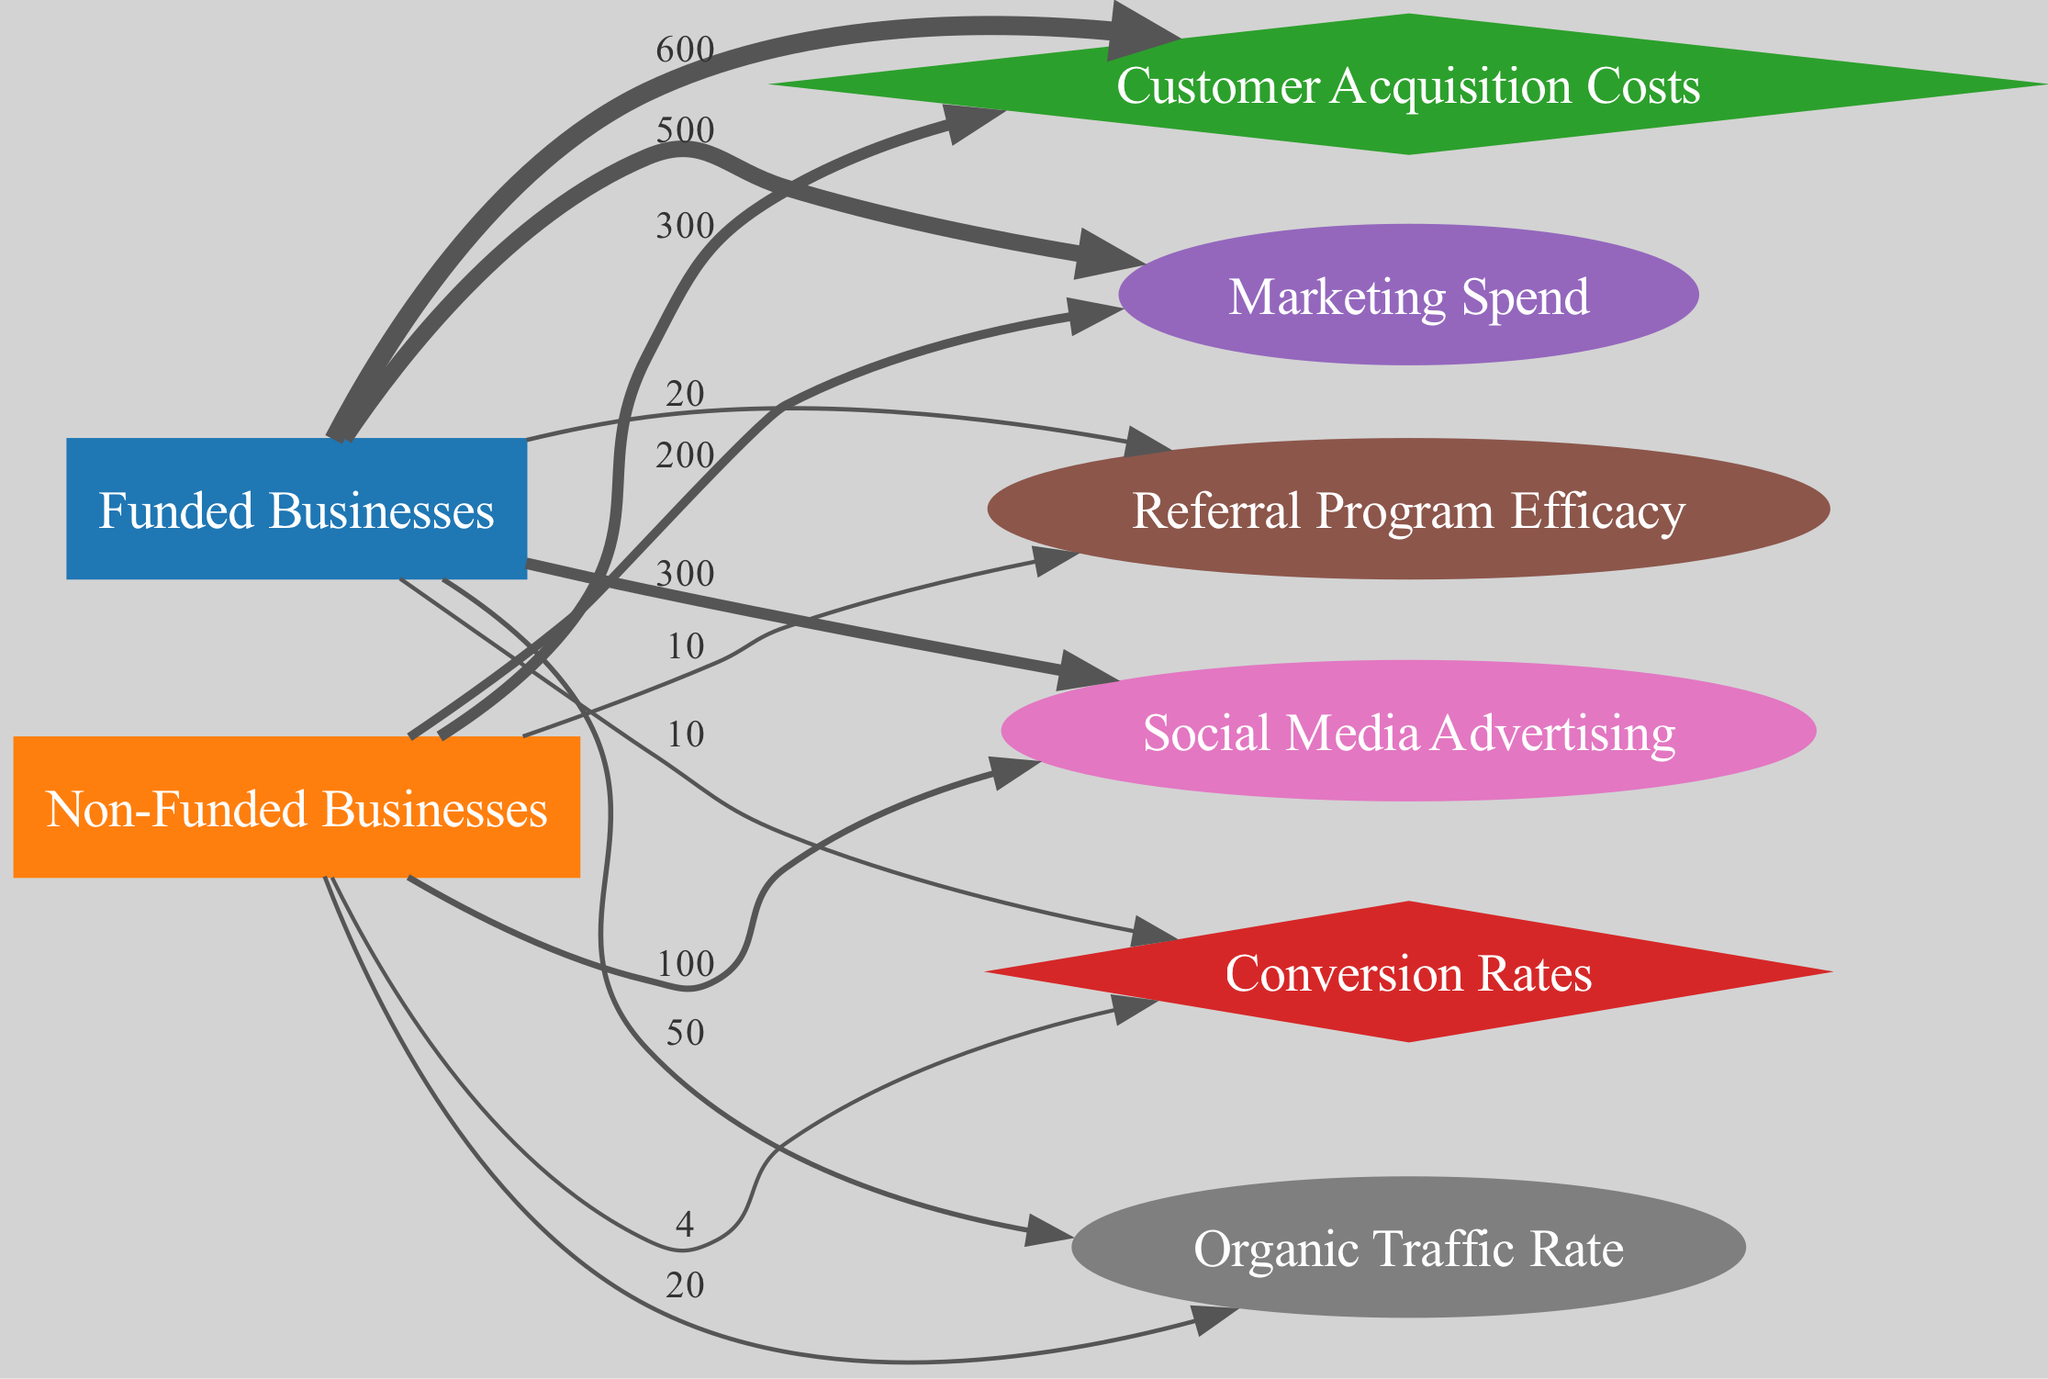What is the total Customer Acquisition Cost for Funded Businesses? The link from "Funded Businesses" to "Customer Acquisition Costs" shows a value of 600, which directly indicates the total cost.
Answer: 600 What is the Conversion Rate for Non-Funded Businesses? The link from "Non-Funded Businesses" to "Conversion Rates" shows a value of 4, directly providing the conversion rate for this category.
Answer: 4 How much more Marketing Spend do Funded Businesses have compared to Non-Funded Businesses? The Marketing Spend is 500 for Funded Businesses and 200 for Non-Funded Businesses. The difference is 500 - 200 = 300.
Answer: 300 What is the total amount of Social Media Advertising for Non-Funded Businesses? The link from "Non-Funded Businesses" to "Social Media Advertising" has a value of 100, indicating the total amount spent on this advertising type.
Answer: 100 Which node has a higher Referral Program Efficacy: Funded or Non-Funded Businesses? The link from "Funded Businesses" shows 20 and from "Non-Funded Businesses" shows 10. Therefore, Funded Businesses have a higher efficacy since 20 > 10.
Answer: Funded Businesses What is the ratio of Customer Acquisition Costs between Funded and Non-Funded Businesses? The Customer Acquisition Cost for Funded Businesses is 600 and for Non-Funded Businesses is 300. The ratio is calculated as 600:300, which simplifies to 2:1.
Answer: 2:1 What is the total Organic Traffic Rate for Non-Funded Businesses? The link showing "Non-Funded Businesses" to "Organic Traffic Rate" has a value of 20, which represents their total organic traffic rate.
Answer: 20 Which intermediate node has the highest value connected to Funded Businesses? Funded Businesses connect to Marketing Spend (500), Social Media Advertising (300), Referral Program Efficacy (20), and Organic Traffic Rate (50). Among these, 500 is the highest.
Answer: Marketing Spend What is the combined Marketing Spend of both types of businesses? The values for Marketing Spend are 500 (Funded) and 200 (Non-Funded). Therefore, the combined total is 500 + 200 = 700.
Answer: 700 